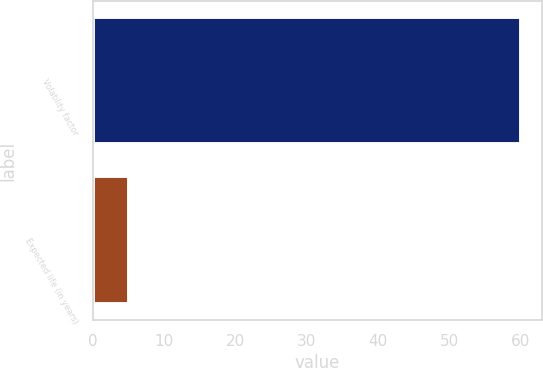Convert chart to OTSL. <chart><loc_0><loc_0><loc_500><loc_500><bar_chart><fcel>Volatility factor<fcel>Expected life (in years)<nl><fcel>60<fcel>5<nl></chart> 